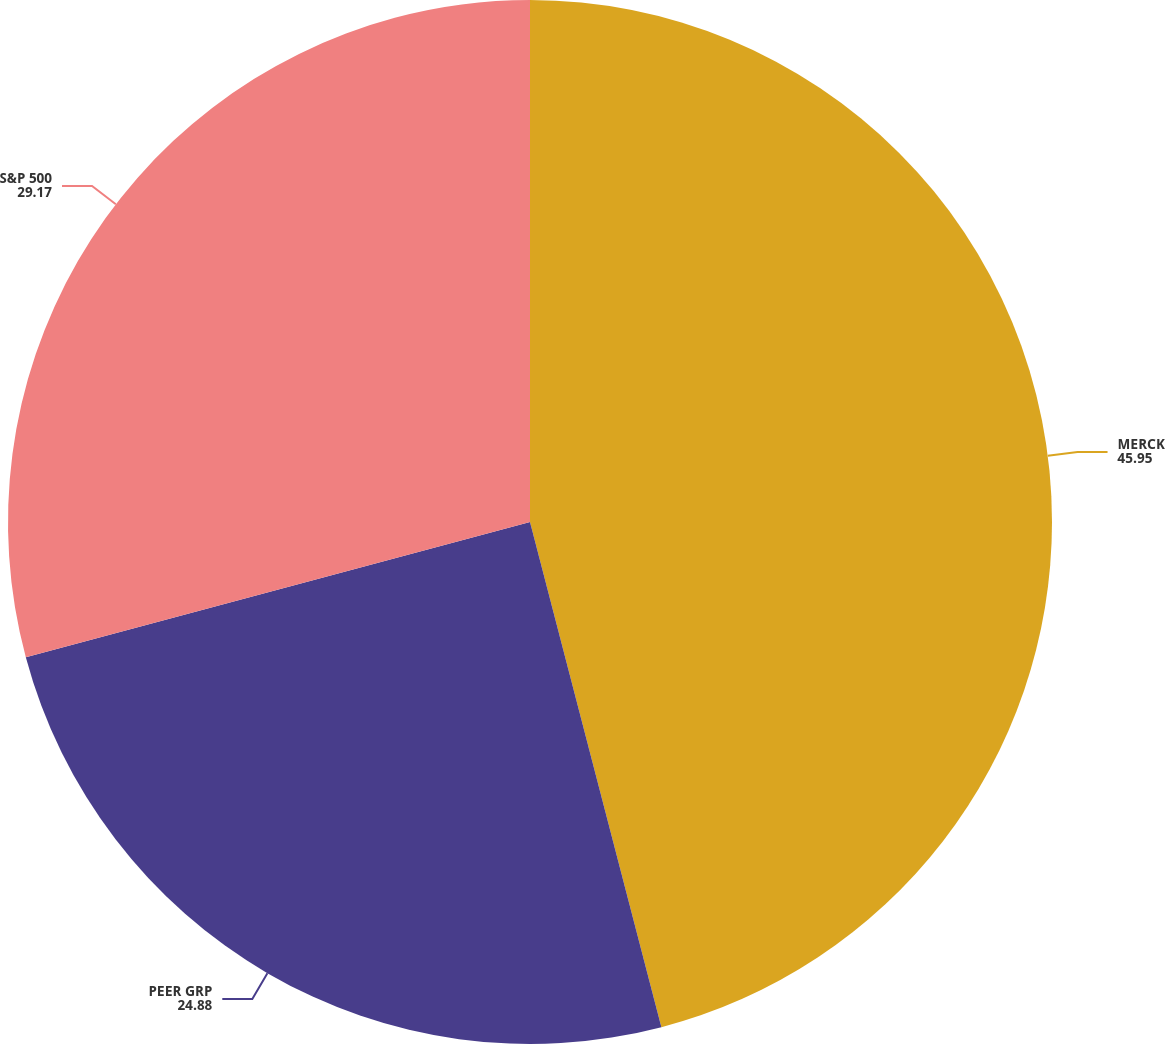Convert chart to OTSL. <chart><loc_0><loc_0><loc_500><loc_500><pie_chart><fcel>MERCK<fcel>PEER GRP<fcel>S&P 500<nl><fcel>45.95%<fcel>24.88%<fcel>29.17%<nl></chart> 